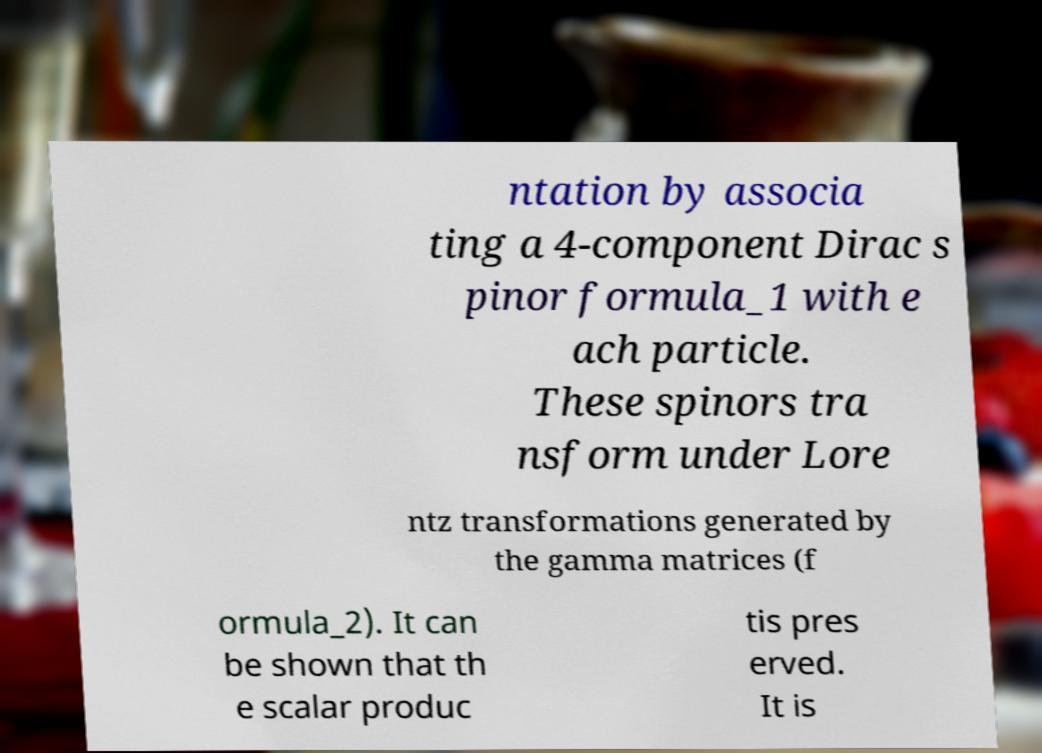Could you extract and type out the text from this image? ntation by associa ting a 4-component Dirac s pinor formula_1 with e ach particle. These spinors tra nsform under Lore ntz transformations generated by the gamma matrices (f ormula_2). It can be shown that th e scalar produc tis pres erved. It is 